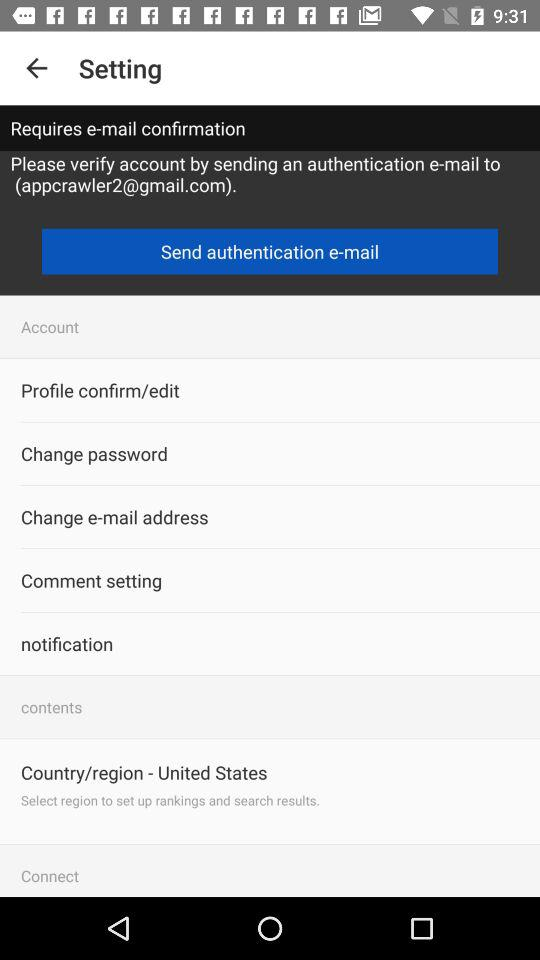What is the email address? The email address is appcrawler2@gmail.com. 